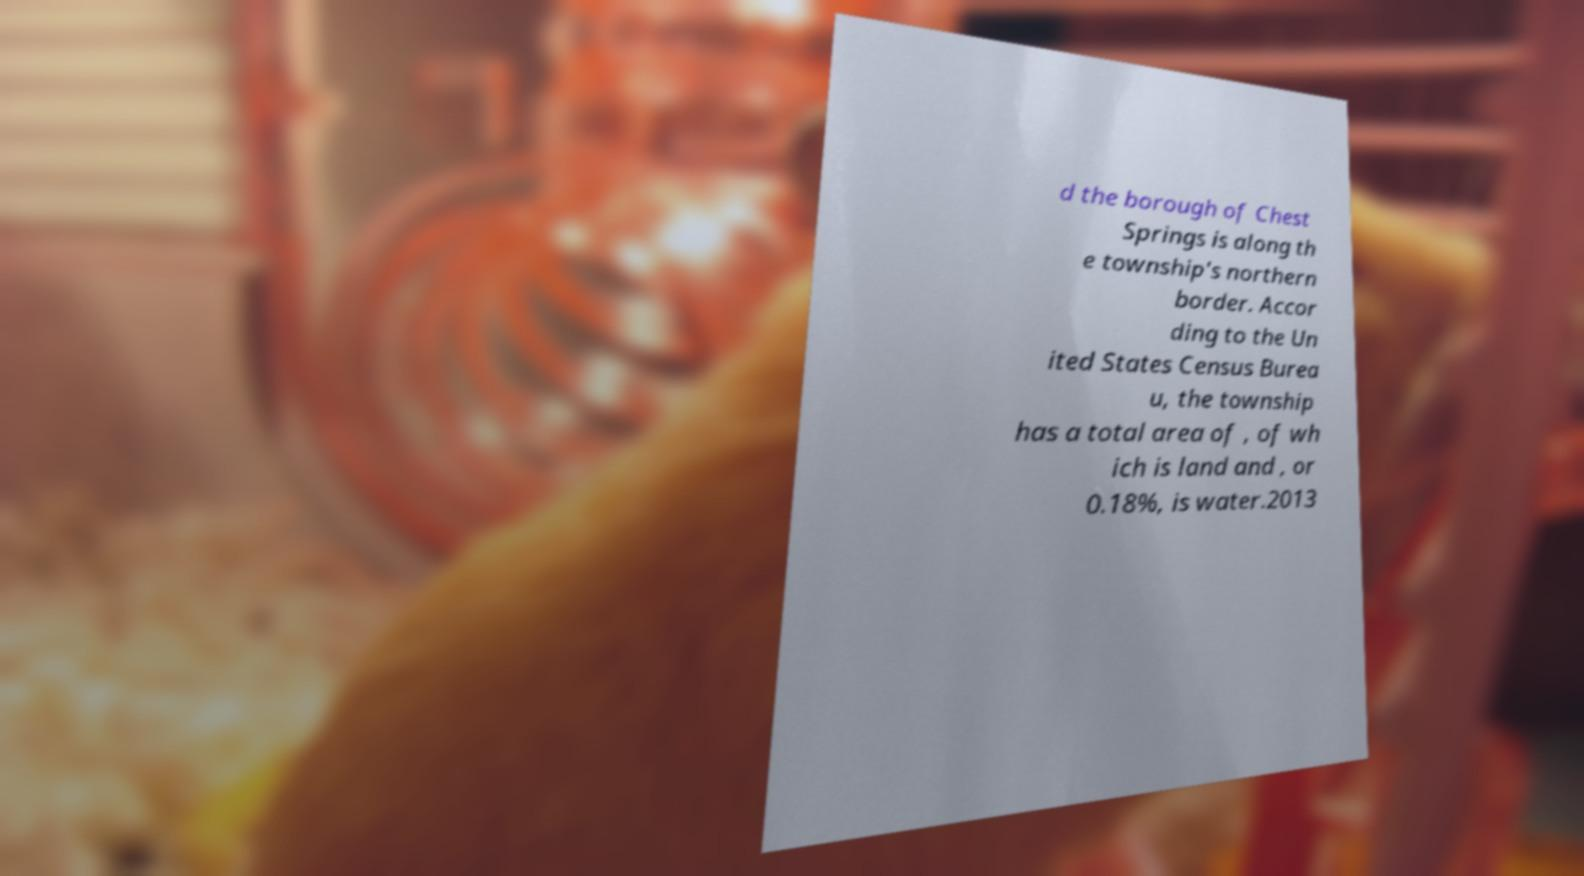Can you accurately transcribe the text from the provided image for me? d the borough of Chest Springs is along th e township's northern border. Accor ding to the Un ited States Census Burea u, the township has a total area of , of wh ich is land and , or 0.18%, is water.2013 